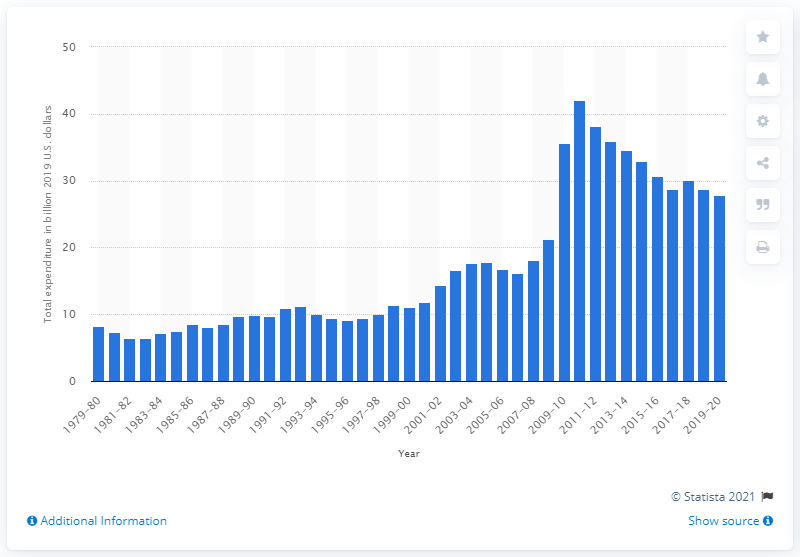Specify some key components in this picture. In the academic year 2019/20, the expenditure on Federal Pell Grants was 27.8%. In the academic year 1979/80, the total expenditure on Federal Pell Grants was $8.3 billion. 